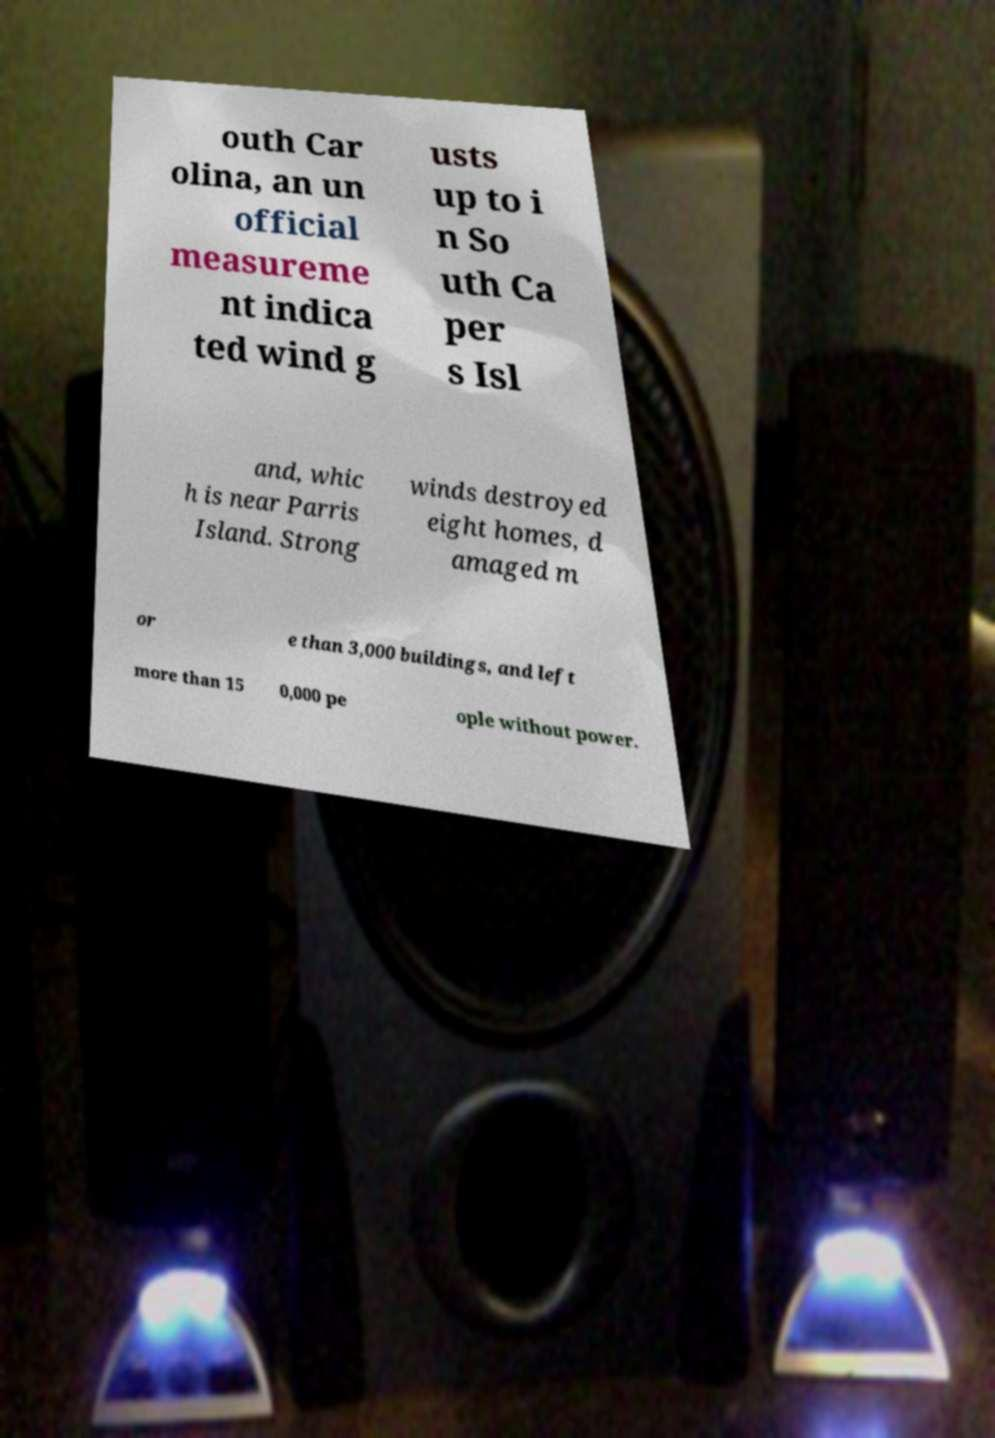Could you assist in decoding the text presented in this image and type it out clearly? outh Car olina, an un official measureme nt indica ted wind g usts up to i n So uth Ca per s Isl and, whic h is near Parris Island. Strong winds destroyed eight homes, d amaged m or e than 3,000 buildings, and left more than 15 0,000 pe ople without power. 